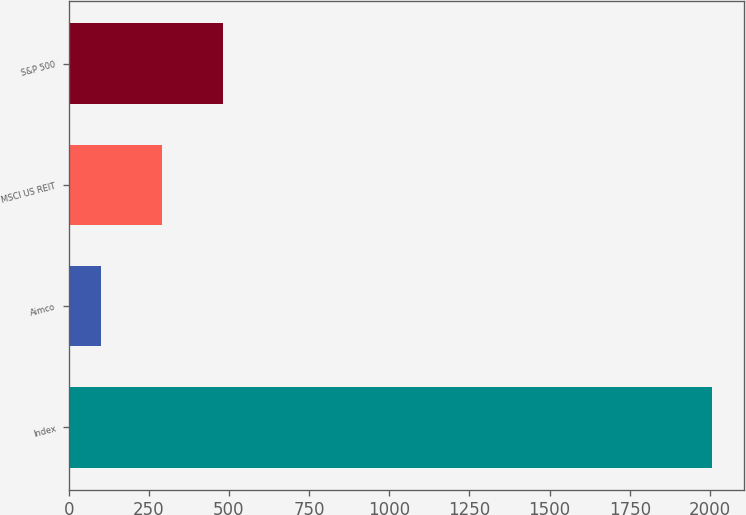<chart> <loc_0><loc_0><loc_500><loc_500><bar_chart><fcel>Index<fcel>Aimco<fcel>MSCI US REIT<fcel>S&P 500<nl><fcel>2007<fcel>100<fcel>290.7<fcel>481.4<nl></chart> 